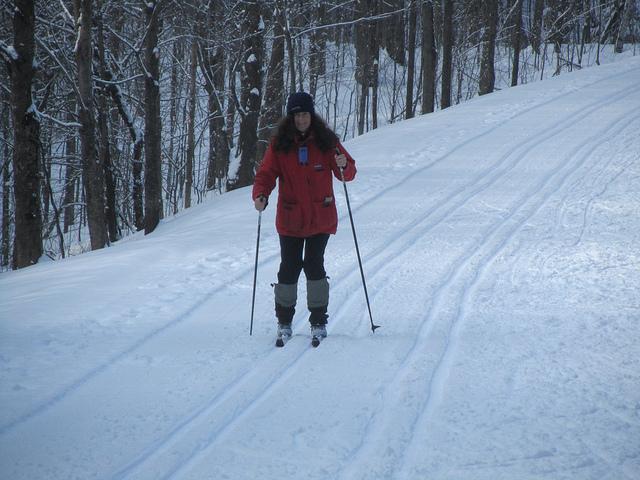What is the woman doing?
Write a very short answer. Skiing. Is her coat open?
Give a very brief answer. No. Is it snowing in the picture?
Short answer required. No. 